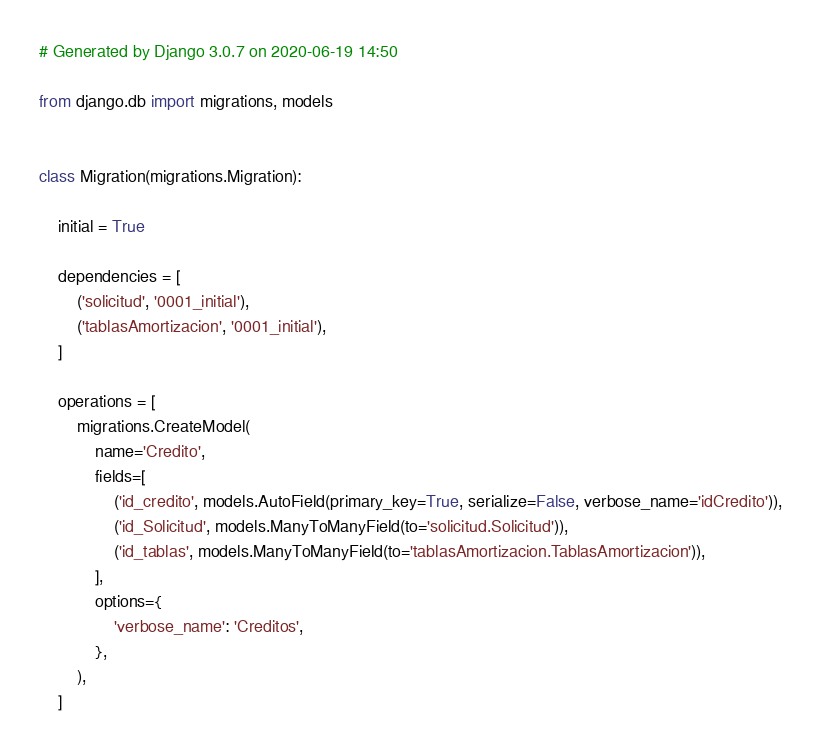<code> <loc_0><loc_0><loc_500><loc_500><_Python_># Generated by Django 3.0.7 on 2020-06-19 14:50

from django.db import migrations, models


class Migration(migrations.Migration):

    initial = True

    dependencies = [
        ('solicitud', '0001_initial'),
        ('tablasAmortizacion', '0001_initial'),
    ]

    operations = [
        migrations.CreateModel(
            name='Credito',
            fields=[
                ('id_credito', models.AutoField(primary_key=True, serialize=False, verbose_name='idCredito')),
                ('id_Solicitud', models.ManyToManyField(to='solicitud.Solicitud')),
                ('id_tablas', models.ManyToManyField(to='tablasAmortizacion.TablasAmortizacion')),
            ],
            options={
                'verbose_name': 'Creditos',
            },
        ),
    ]
</code> 